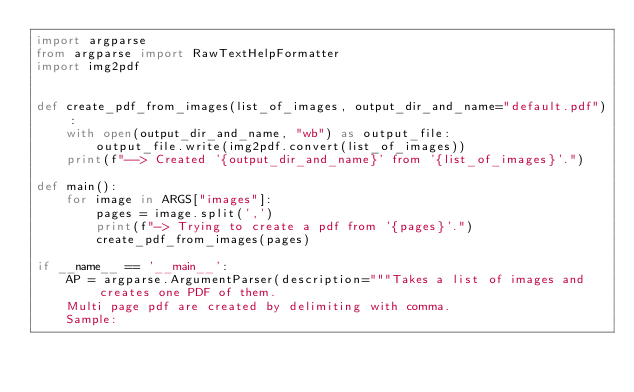<code> <loc_0><loc_0><loc_500><loc_500><_Python_>import argparse
from argparse import RawTextHelpFormatter
import img2pdf


def create_pdf_from_images(list_of_images, output_dir_and_name="default.pdf"):
    with open(output_dir_and_name, "wb") as output_file:
        output_file.write(img2pdf.convert(list_of_images))
    print(f"--> Created '{output_dir_and_name}' from '{list_of_images}'.")

def main():
    for image in ARGS["images"]:
        pages = image.split(',')
        print(f"-> Trying to create a pdf from '{pages}'.")
        create_pdf_from_images(pages)

if __name__ == '__main__':
    AP = argparse.ArgumentParser(description="""Takes a list of images and creates one PDF of them.
    Multi page pdf are created by delimiting with comma.
    Sample:</code> 